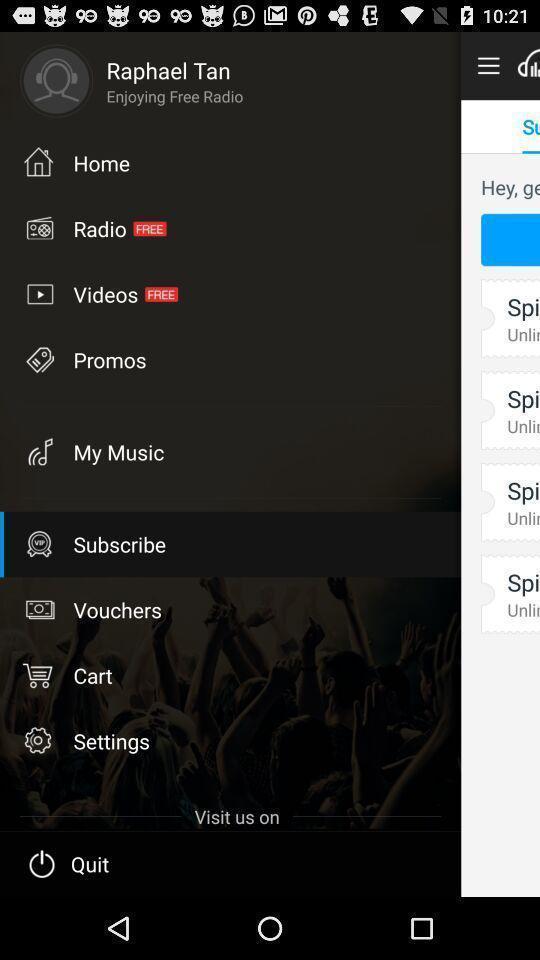Give me a summary of this screen capture. Page showing different options. 